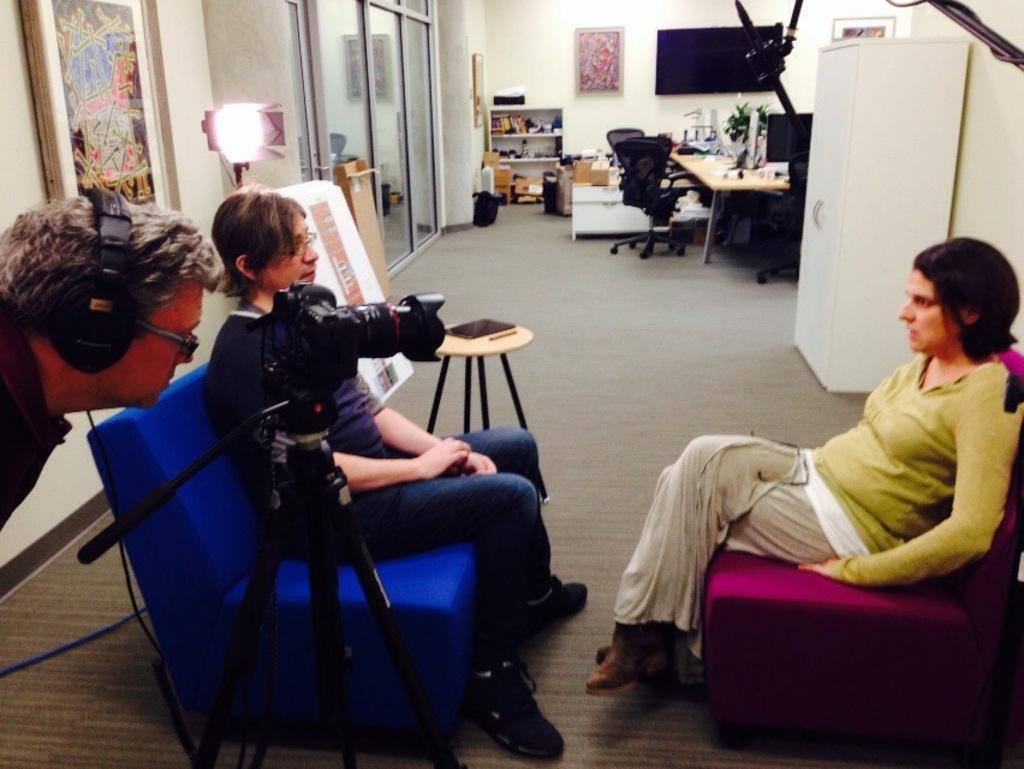Please provide a concise description of this image. 2 sitting are sitting on the sofa, facing each other. in the front there is a person wearing headset watching at the camera. at the back there is a table, chairs, shelves , books. at the left corner of the wall there is a photo frame. 